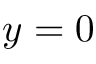<formula> <loc_0><loc_0><loc_500><loc_500>y = 0</formula> 